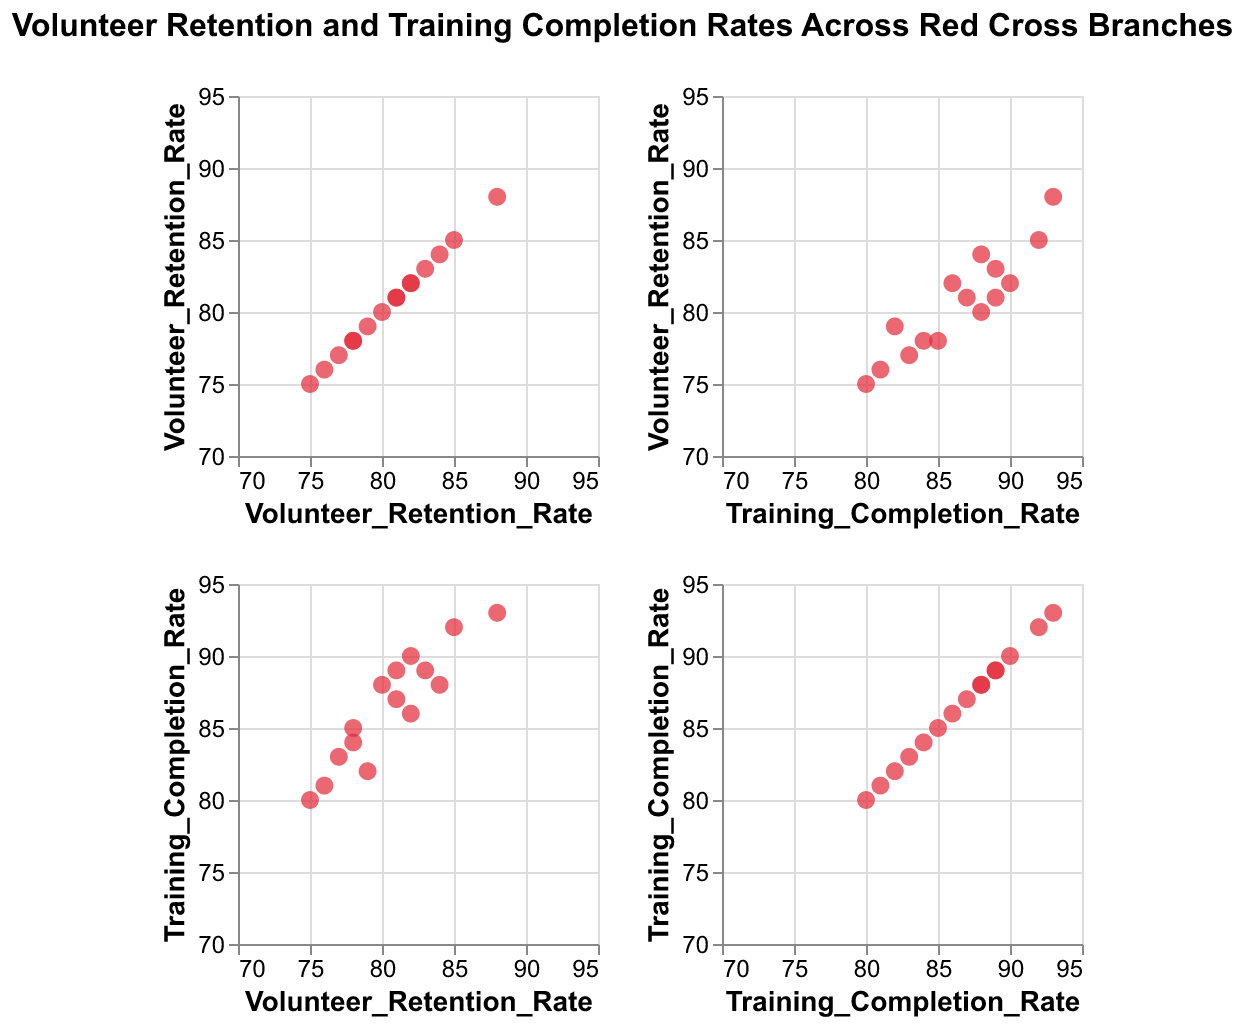What is the main focus of the scatter plot matrix (SPLOM)? The title of the chart provides this information. The SPLOM focuses on Volunteer Retention and Training Completion Rates across various Red Cross branches.
Answer: Volunteer Retention and Training Completion Rates Across Red Cross Branches How many branches are represented in the scatter plot matrix? Count the number of unique data points indicated by different branches in the scatter plot matrix. Each data point corresponds to a branch.
Answer: 15 Which branch has the highest Volunteer Retention Rate? Locate the highest value on the Volunteer Retention Rate axis and find the corresponding branch from the tooltip information or label.
Answer: San_Diego What is the average Training Completion Rate across all branches? Add all the Training Completion Rate values and divide by the number of branches. (92 + 88 + 85 + 90 + 80 + 83 + 87 + 93 + 89 + 81 + 86 + 82 + 88 + 84 + 89) / 15 = 1317 / 15 ≈ 87.8
Answer: 87.8 Which branch has both high Volunteer Retention Rate and high Training Completion Rate? Look for data points located in the upper-right quadrant of the scatter plot matrix where both Volunteer Retention Rate and Training Completion Rate are high.
Answer: San_Diego Is there a branch with a Volunteer Retention Rate below 80% but a Training Completion Rate above 85%? Identify data points with a Volunteer Retention Rate below 80% and then check if any of them have a Training Completion Rate above 85%. The branch is Chicago with 78% Volunteer Retention Rate and 85% Training Completion Rate.
Answer: Chicago What is the difference in Volunteer Retention Rate between San Diego and Phoenix branches? Find the Volunteer Retention Rates for San Diego and Phoenix, then subtract the Phoenix rate from the San Diego rate. (88 - 75) = 13
Answer: 13 How do the majority of branches perform in terms of Training Completion Rate? Analyze the distribution of data points in the scatter plot matrix with regard to the Training Completion Rate axis. Most branches have a Training Completion Rate clustered around 85%-90%.
Answer: Around 85%-90% Which two branches have the closest Volunteer Retention Rates and what are these rates? Compare the Volunteer Retention Rates and find the two branches with the least difference in their rates. Look for branches whose retention rates are close. Anaheim and Houston both have close Volunteer Retention Rates of 82%.
Answer: Austin and Houston, 82% Is there a positive correlation between Volunteer Retention Rate and Training Completion Rate? Observe the overall trend in the scatter plot matrix. If higher Volunteer Retention Rates are generally associated with higher Training Completion Rates, there is a positive correlation.
Answer: Yes 